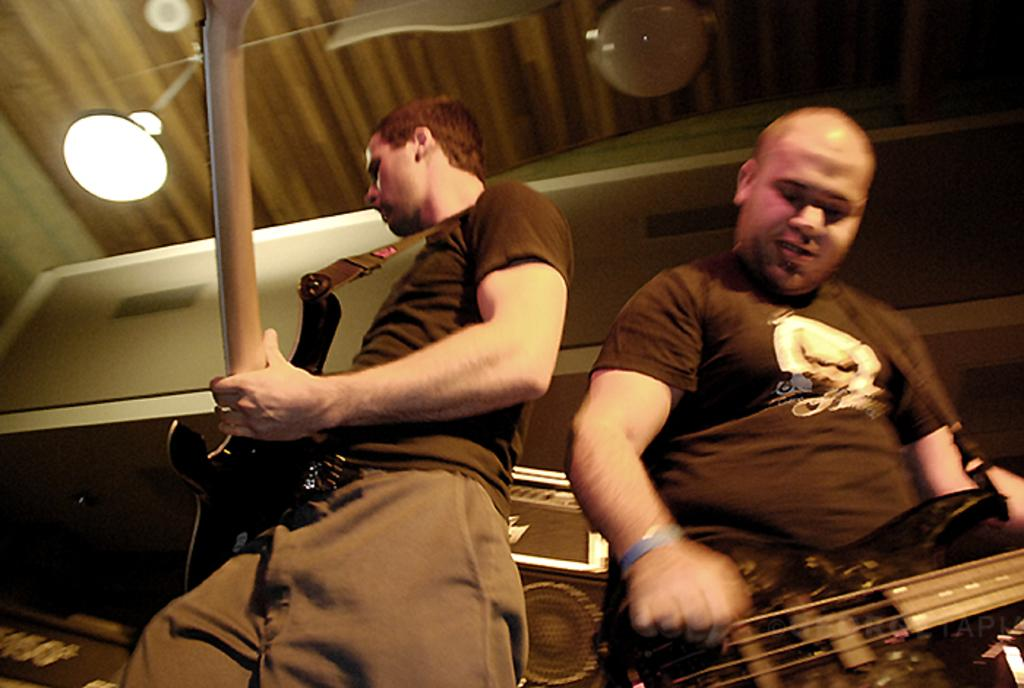How many people are in the image? There are two persons in the image. What are the persons doing in the image? The persons are playing guitar. What position are the persons in? The persons are standing. What can be seen providing illumination in the image? There is a light visible in the image. What device is present for amplifying sound? There is a speaker in the image. What object can be seen that might be used for storage or transportation? There is a box in the image. What type of smoke can be seen coming from the guitar in the image? There is no smoke coming from the guitar in the image. What emotion do the persons in the image seem to be expressing through their actions? The provided facts do not give information about the emotions of the persons in the image. 